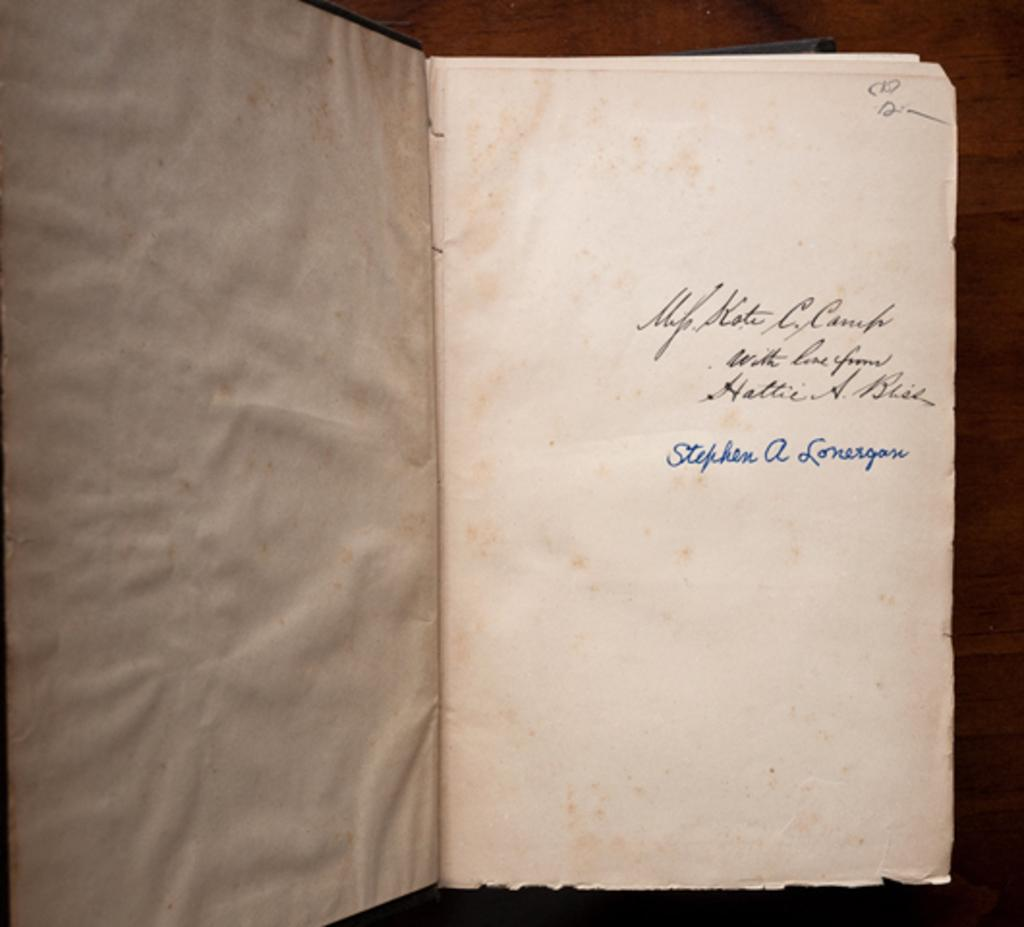<image>
Write a terse but informative summary of the picture. a book open to a page written in pen and signed Stephen A Lonergan 